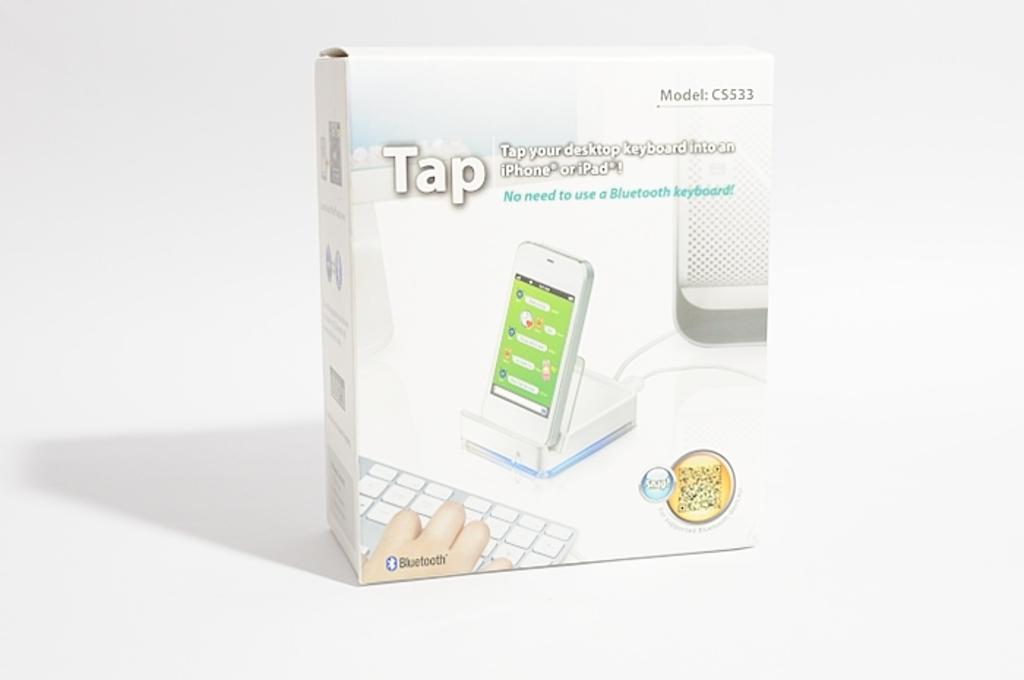<image>
Share a concise interpretation of the image provided. A box with a cell phone on a charger that says Tap on it. 